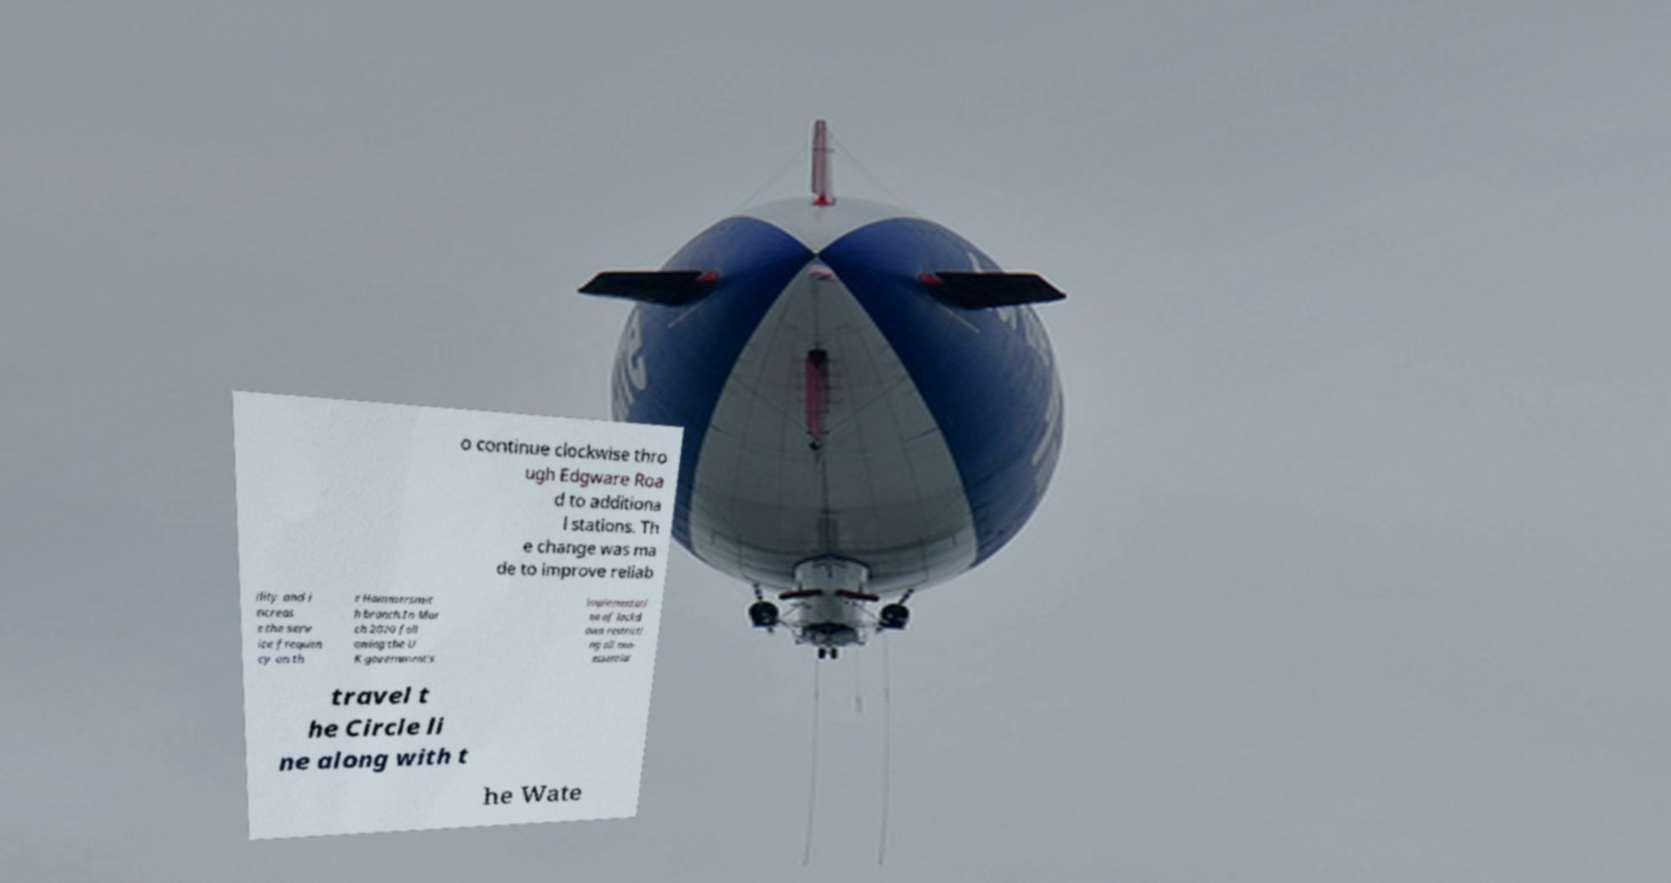Could you assist in decoding the text presented in this image and type it out clearly? o continue clockwise thro ugh Edgware Roa d to additiona l stations. Th e change was ma de to improve reliab ility and i ncreas e the serv ice frequen cy on th e Hammersmit h branch.In Mar ch 2020 foll owing the U K government's implementati on of lockd own restricti ng all non- essential travel t he Circle li ne along with t he Wate 